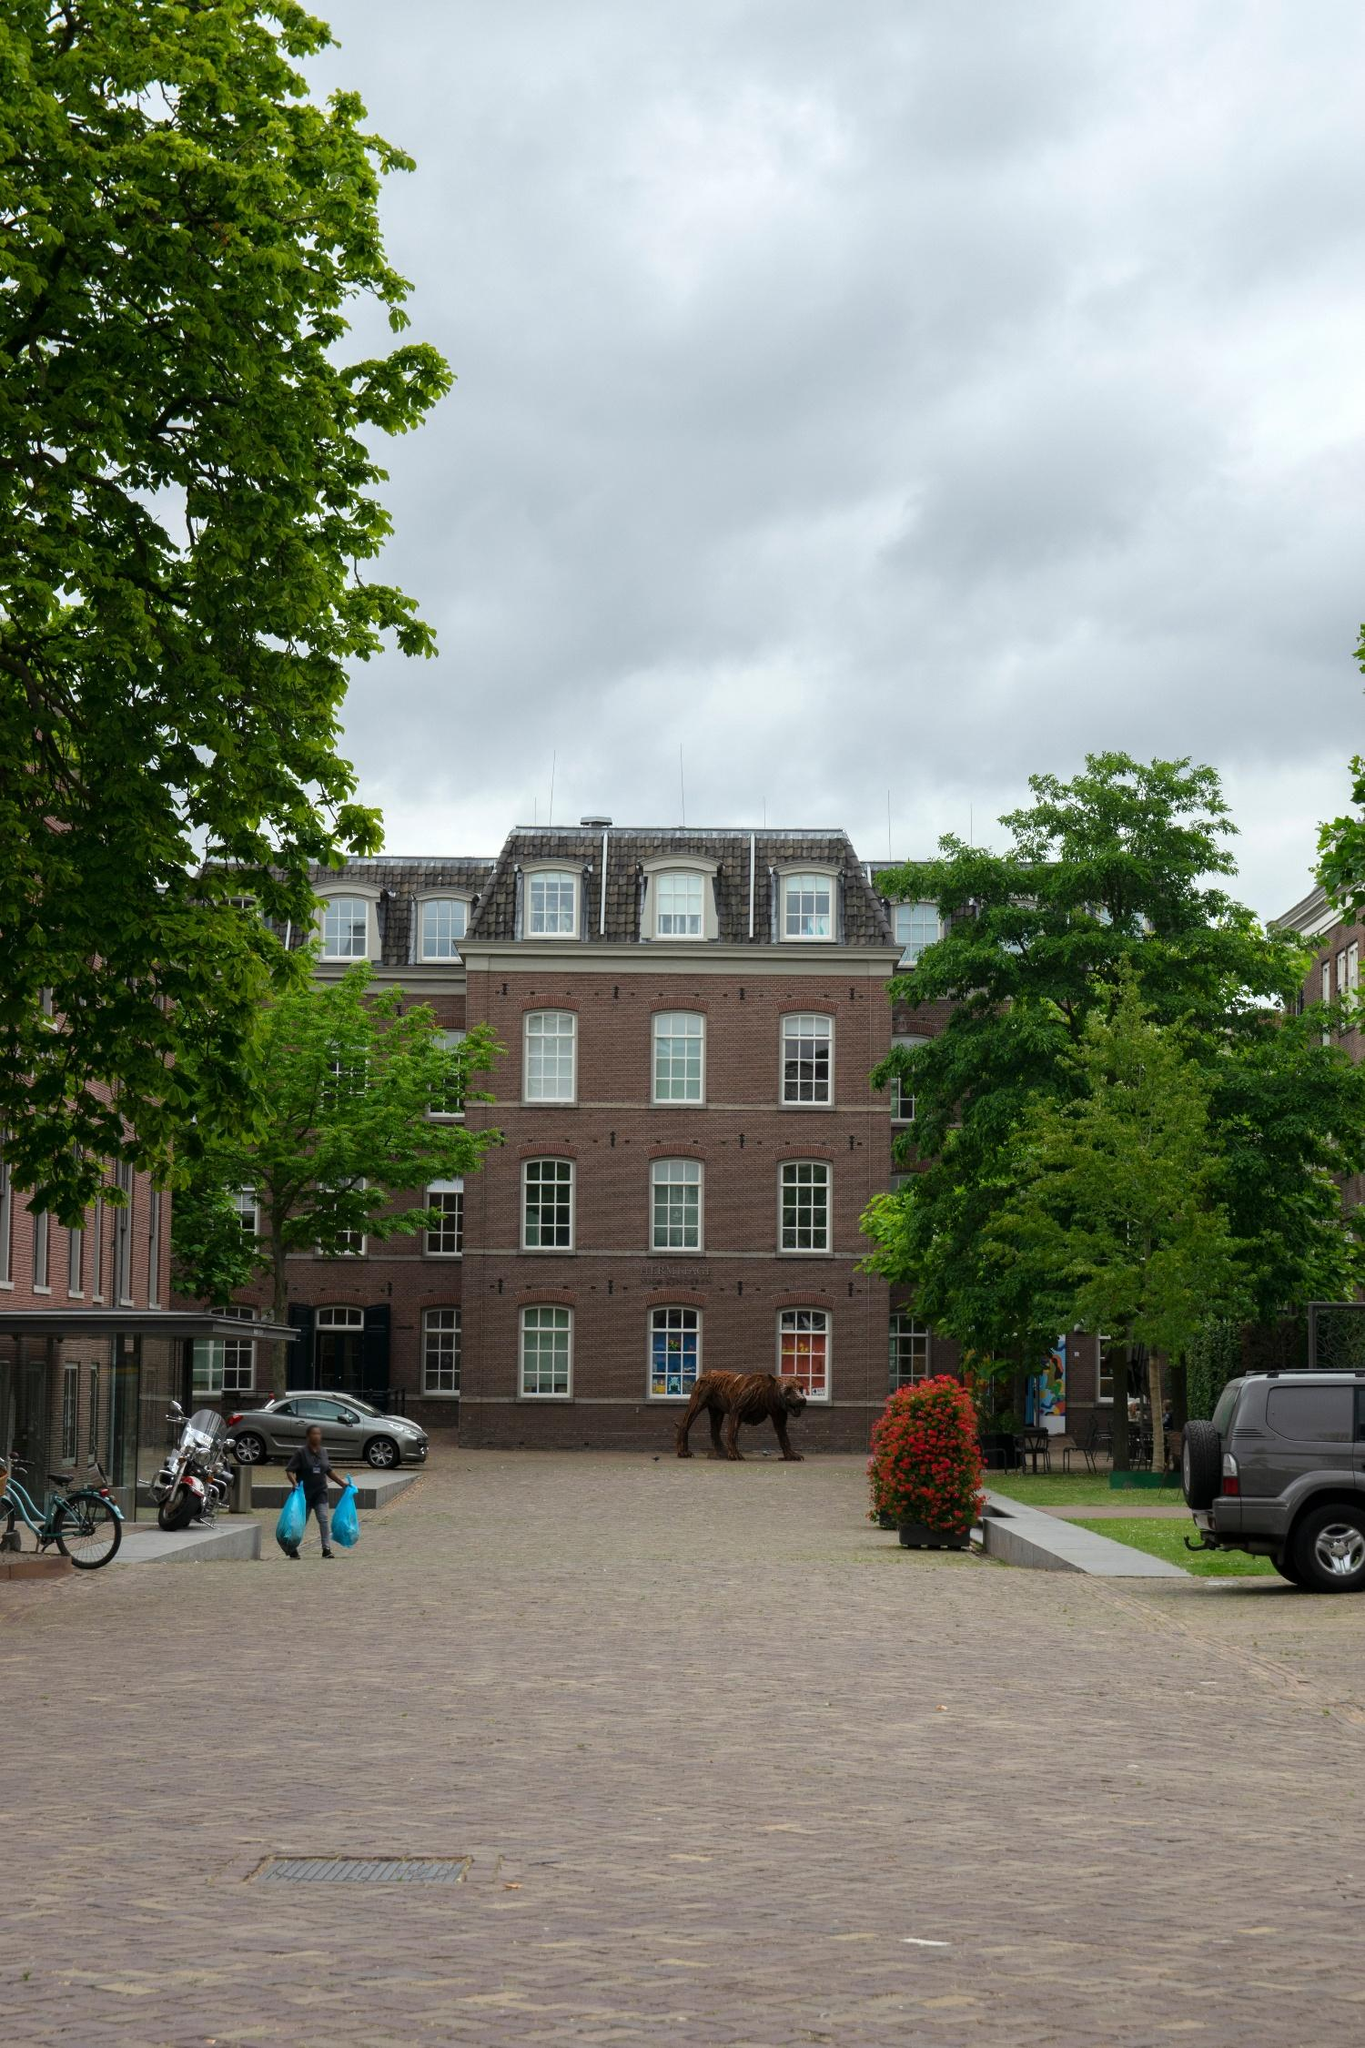Imagine if the sculpture could talk, what would it say about its place in the neighborhood? If the sculpture could talk, it might share tales of the neighborhood's evolution over time. It would speak fondly of the quiet moments it witnessed, the daily routines of the residents, and the changing seasons. The bear might express pride in being an emblem of the community's artistic spirit and resilience. It would recount how it enjoyed the soft murmurs of conversations, the laughter of children playing, and the peaceful solitude during the nights. The bear would emphasize the importance of art in everyday life, making the ordinary streets extraordinary. 